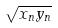<formula> <loc_0><loc_0><loc_500><loc_500>\sqrt { x _ { n } y _ { n } }</formula> 